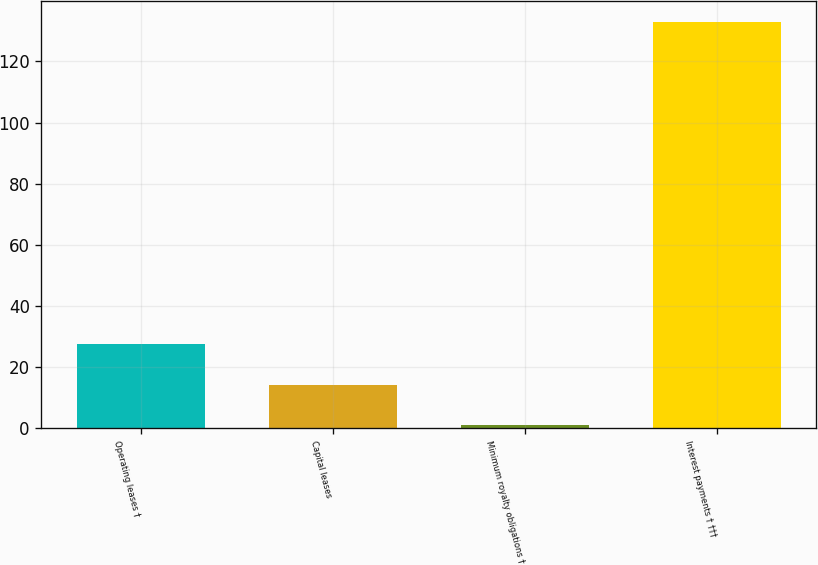Convert chart. <chart><loc_0><loc_0><loc_500><loc_500><bar_chart><fcel>Operating leases †<fcel>Capital leases<fcel>Minimum royalty obligations †<fcel>Interest payments † †††<nl><fcel>27.4<fcel>14.2<fcel>1<fcel>133<nl></chart> 